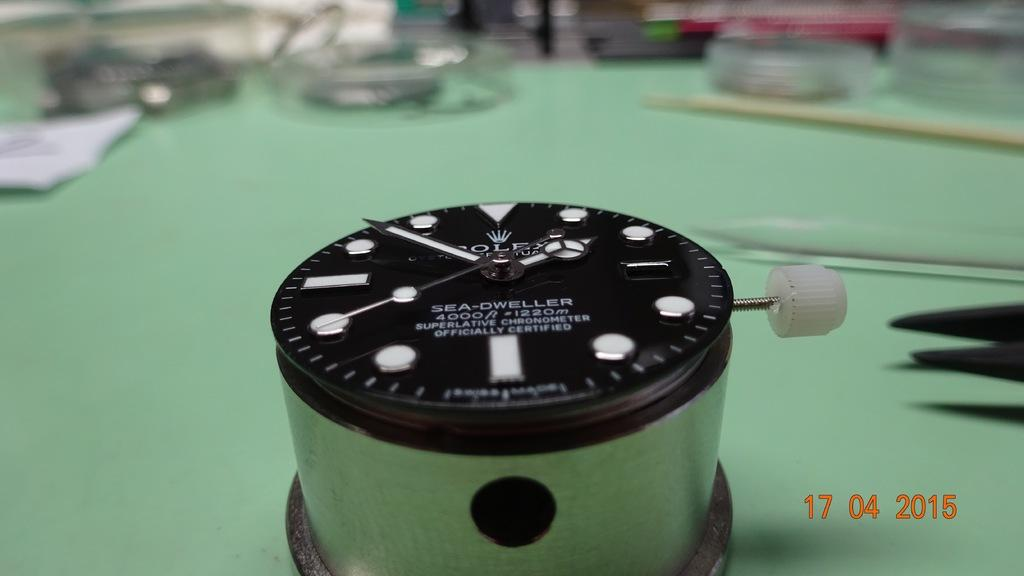<image>
Summarize the visual content of the image. A clock like device called sea dweller sits on a green table 